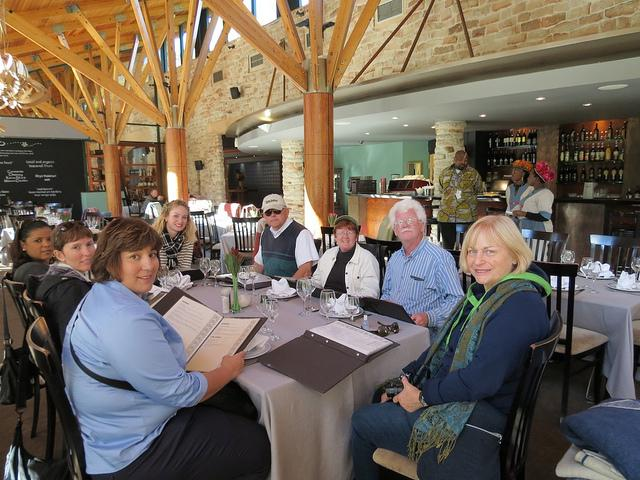What will persons seated here do next?

Choices:
A) order
B) sing
C) pay
D) leave order 